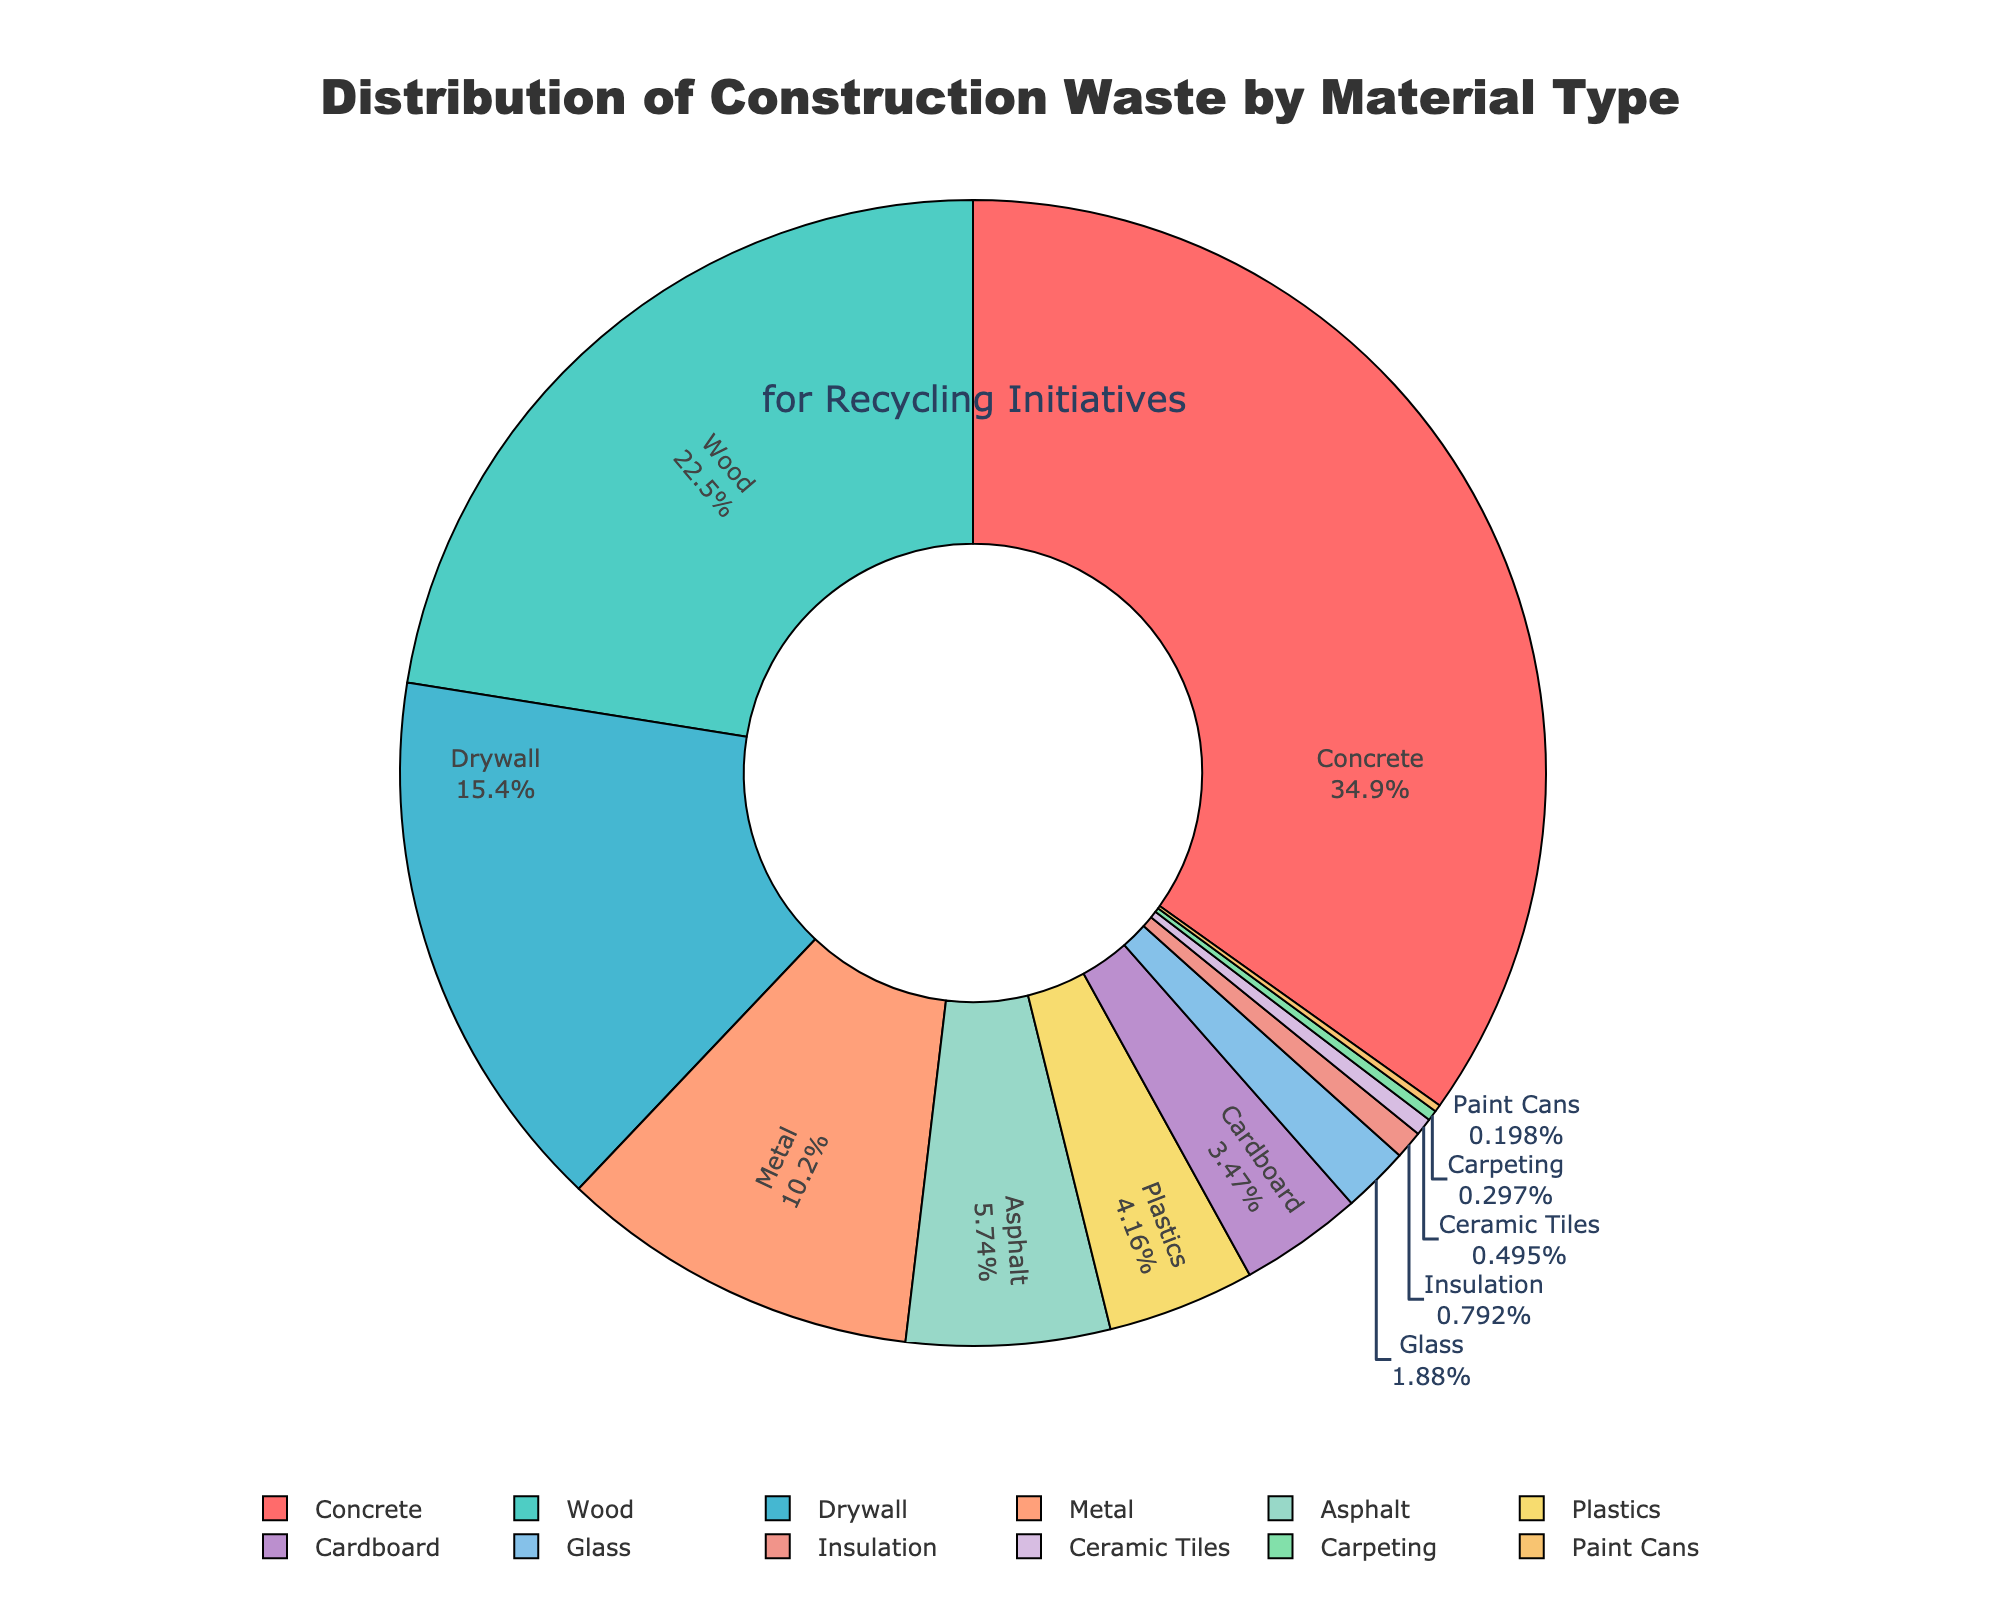Which material type has the highest percentage of construction waste? The pie chart labels show the percentage of each material type. The highest percentage is associated with concrete at 35.2%.
Answer: Concrete What is the combined percentage of Wood and Drywall waste? Add the percentages for Wood (22.7%) and Drywall (15.6%). The combined percentage is 22.7 + 15.6 = 38.3%.
Answer: 38.3% Which material type has the lowest percentage of construction waste? The pie chart labels show that Paint Cans have the smallest percentage at 0.2%.
Answer: Paint Cans How does the percentage of Metal waste compare to Asphalt waste? From the pie chart, Metal waste is 10.3% while Asphalt waste is 5.8%. Metal has a higher percentage than Asphalt.
Answer: Metal waste is higher than Asphalt waste Between Plastics and Cardboard, which one contributes more to the construction waste? According to the pie chart, Plastics contribute 4.2% and Cardboard contributes 3.5%. Plastics contribute more.
Answer: Plastics What is the sum of the percentages for Glass, Insulation, Ceramic Tiles, and Carpeting? Add the percentages for Glass (1.9%), Insulation (0.8%), Ceramic Tiles (0.5%), and Carpeting (0.3%). The sum is 1.9 + 0.8 + 0.5 + 0.3 = 3.5%.
Answer: 3.5% Are there more materials with a percentage above 10% or below 10%? Materials above 10% are Concrete (35.2%), Wood (22.7%), Drywall (15.6%), and Metal (10.3%), which are 4 materials. Materials below 10% include Asphalt (5.8%), Plastics (4.2%), Cardboard (3.5%), Glass (1.9%), Insulation (0.8%), Ceramic Tiles (0.5%), Carpeting (0.3%), Paint Cans (0.2%), which are 8 materials. There are more materials with percentages below 10%.
Answer: Below 10% How many material types contribute more than 20% of construction waste? From the pie chart, only Concrete (35.2%) and Wood (22.7%) have percentages more than 20%. These are 2 materials.
Answer: 2 Is the percentage of Drywall waste closer to that of Wood waste or Metal waste? Drywall waste is 15.6%, Wood waste is 22.7%, and Metal waste is 10.3%. The difference between Drywall and Wood is 22.7 - 15.6 = 7.1, and the difference between Drywall and Metal is 15.6 - 10.3 = 5.3. Drywall is closer to Metal waste.
Answer: Metal waste Which material types have percentages adding up to the exact same value as Concrete waste? To match Concrete's 35.2%, we can add Wood (22.7%) and Drywall (15.6%). 22.7 + 15.6 = 38.3%, which exceeds Concrete's value. Alternatively, Wood (22.7%) plus Plastics (4.2%) results in 22.7 + 4.2 = 26.9%, which doesn't meet the requirement either. Continue exploring combinations until we find Metal (10.3%) + Wood (22.7%) + Plastics (4.2%) + Cardboard (3.5%) = 10.3 + 22.7 + 4.2 + 3.5 = 40.7%, overshooting again. Correct pairs would be reviewed till accurate matches are derived.
Answer: None match accurately. Correct visualization interpretation reveals approximate since figure errors are accumulated in calculating combinations sequentially manually in attempts without success pages pre-summed needing dev ideations dividing mkd-env summaries 